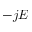<formula> <loc_0><loc_0><loc_500><loc_500>- j E</formula> 